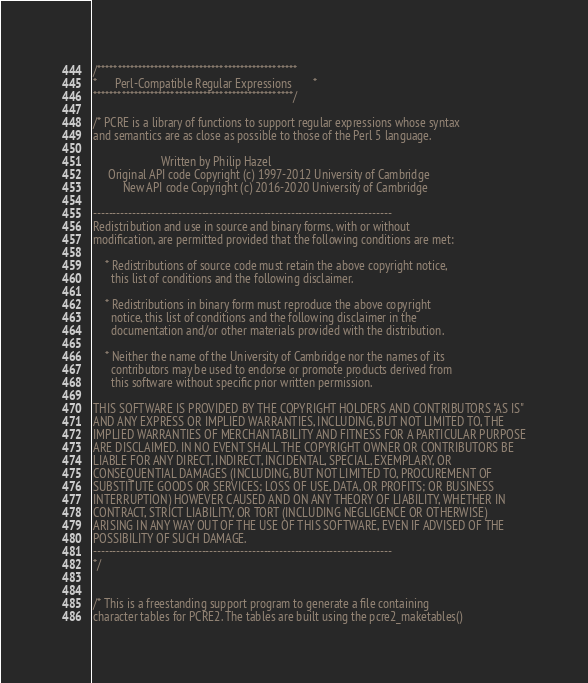Convert code to text. <code><loc_0><loc_0><loc_500><loc_500><_C_>/*************************************************
*      Perl-Compatible Regular Expressions       *
*************************************************/

/* PCRE is a library of functions to support regular expressions whose syntax
and semantics are as close as possible to those of the Perl 5 language.

                       Written by Philip Hazel
     Original API code Copyright (c) 1997-2012 University of Cambridge
          New API code Copyright (c) 2016-2020 University of Cambridge

-----------------------------------------------------------------------------
Redistribution and use in source and binary forms, with or without
modification, are permitted provided that the following conditions are met:

    * Redistributions of source code must retain the above copyright notice,
      this list of conditions and the following disclaimer.

    * Redistributions in binary form must reproduce the above copyright
      notice, this list of conditions and the following disclaimer in the
      documentation and/or other materials provided with the distribution.

    * Neither the name of the University of Cambridge nor the names of its
      contributors may be used to endorse or promote products derived from
      this software without specific prior written permission.

THIS SOFTWARE IS PROVIDED BY THE COPYRIGHT HOLDERS AND CONTRIBUTORS "AS IS"
AND ANY EXPRESS OR IMPLIED WARRANTIES, INCLUDING, BUT NOT LIMITED TO, THE
IMPLIED WARRANTIES OF MERCHANTABILITY AND FITNESS FOR A PARTICULAR PURPOSE
ARE DISCLAIMED. IN NO EVENT SHALL THE COPYRIGHT OWNER OR CONTRIBUTORS BE
LIABLE FOR ANY DIRECT, INDIRECT, INCIDENTAL, SPECIAL, EXEMPLARY, OR
CONSEQUENTIAL DAMAGES (INCLUDING, BUT NOT LIMITED TO, PROCUREMENT OF
SUBSTITUTE GOODS OR SERVICES; LOSS OF USE, DATA, OR PROFITS; OR BUSINESS
INTERRUPTION) HOWEVER CAUSED AND ON ANY THEORY OF LIABILITY, WHETHER IN
CONTRACT, STRICT LIABILITY, OR TORT (INCLUDING NEGLIGENCE OR OTHERWISE)
ARISING IN ANY WAY OUT OF THE USE OF THIS SOFTWARE, EVEN IF ADVISED OF THE
POSSIBILITY OF SUCH DAMAGE.
-----------------------------------------------------------------------------
*/


/* This is a freestanding support program to generate a file containing
character tables for PCRE2. The tables are built using the pcre2_maketables()</code> 